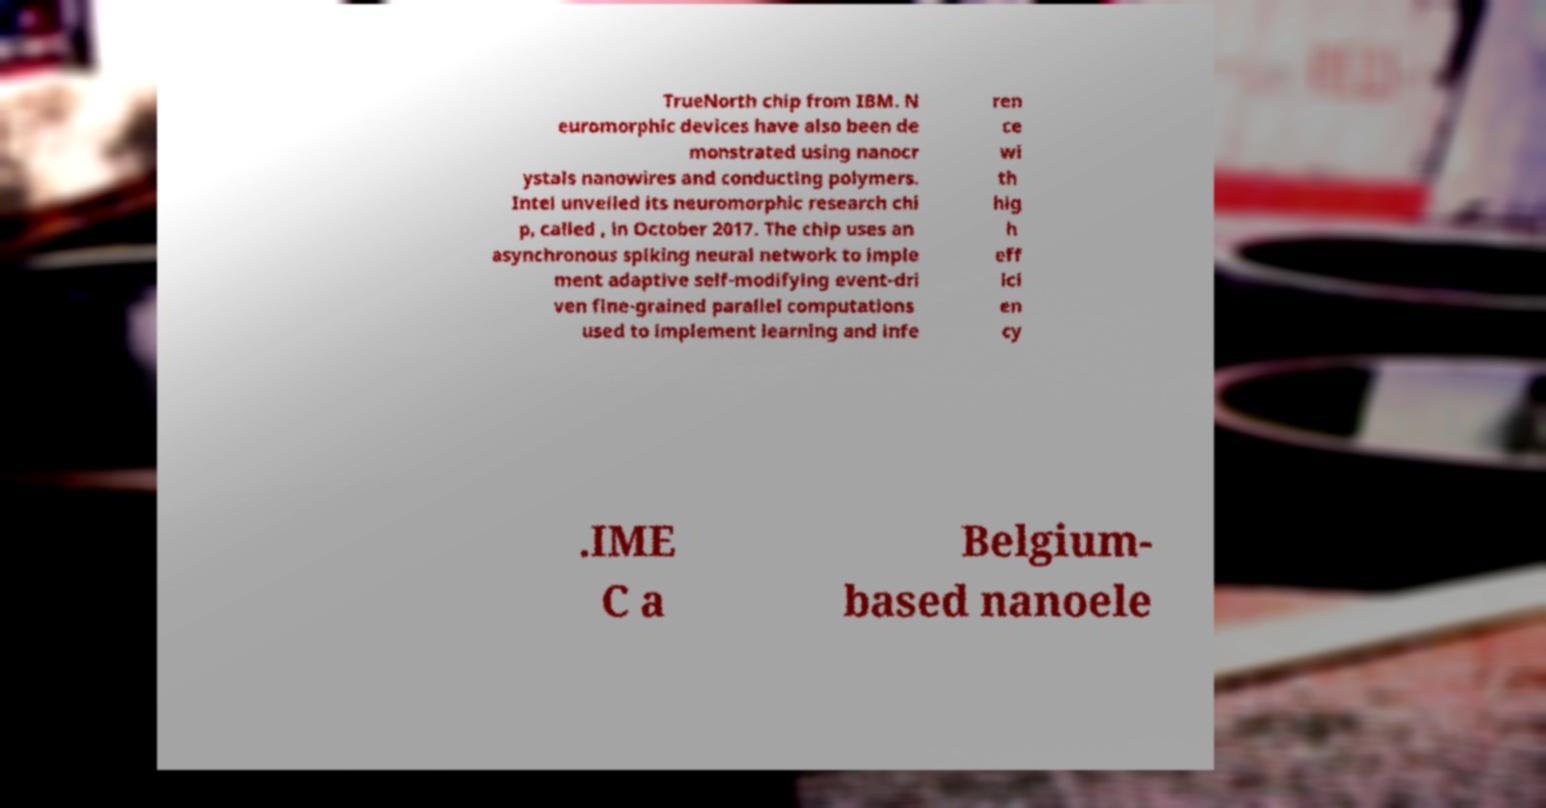Can you read and provide the text displayed in the image?This photo seems to have some interesting text. Can you extract and type it out for me? TrueNorth chip from IBM. N euromorphic devices have also been de monstrated using nanocr ystals nanowires and conducting polymers. Intel unveiled its neuromorphic research chi p, called , in October 2017. The chip uses an asynchronous spiking neural network to imple ment adaptive self-modifying event-dri ven fine-grained parallel computations used to implement learning and infe ren ce wi th hig h eff ici en cy .IME C a Belgium- based nanoele 